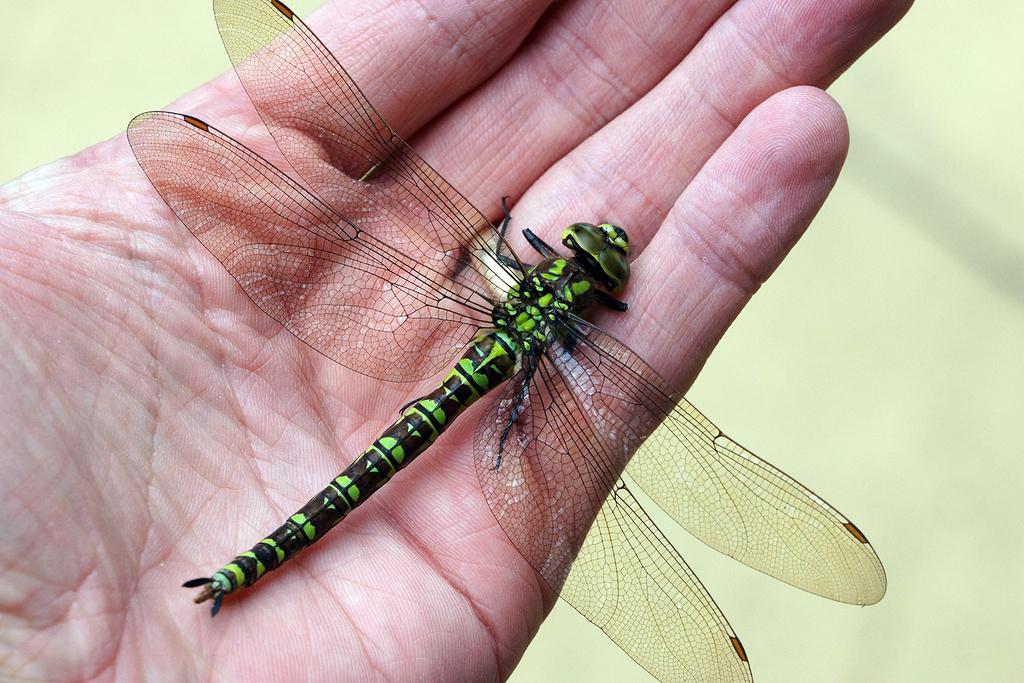In one or two sentences, can you explain what this image depicts? In the image we can see hand, in the hand there is a dragonfly. Background of the image is blur. 